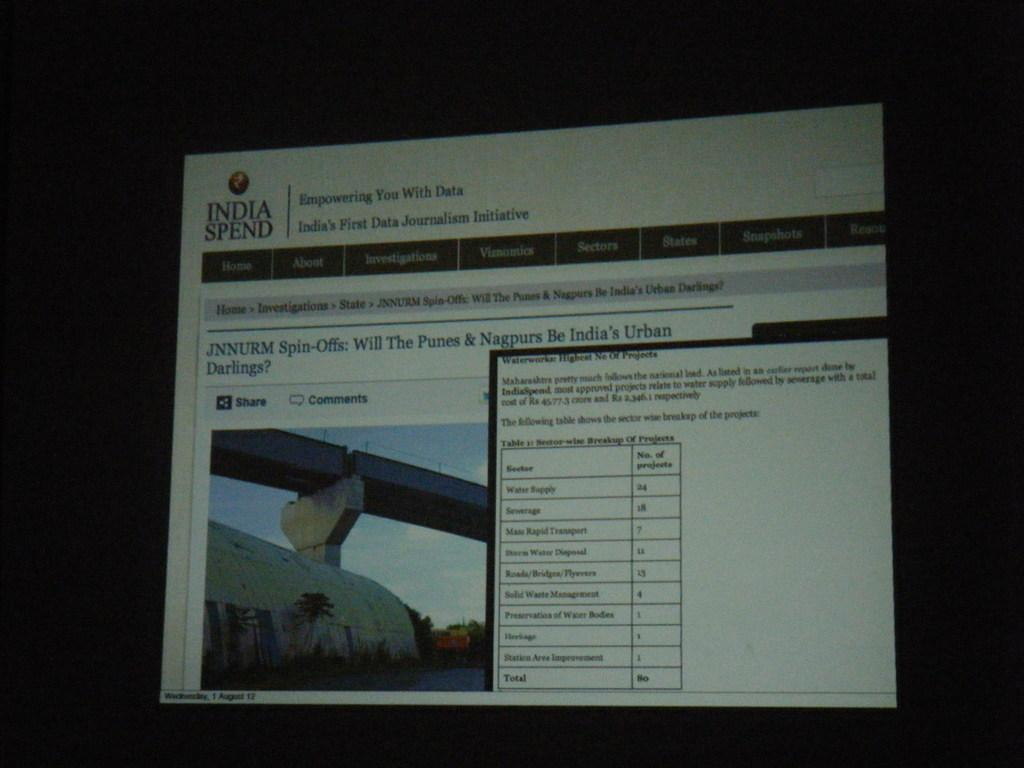<image>
Render a clear and concise summary of the photo. a photo on a computer that is related to spin offs 